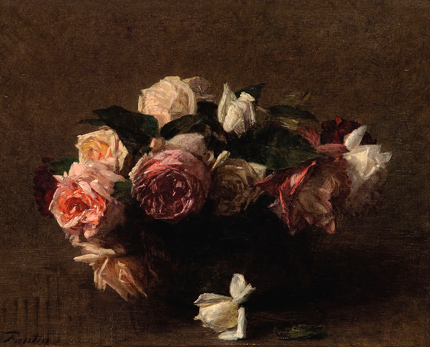What do the different colors of the roses in the painting symbolize? The varied hues in the bouquet could represent a spectrum of emotions or states, common in floral symbolism. Pink roses often symbolize admiration and grace, white roses suggest purity and innocence, and red roses are traditionally associated with love and passion. In the context of this painting, these colors might suggest a complex interplay of feelings or a celebration of diversity in beauty and expression. 